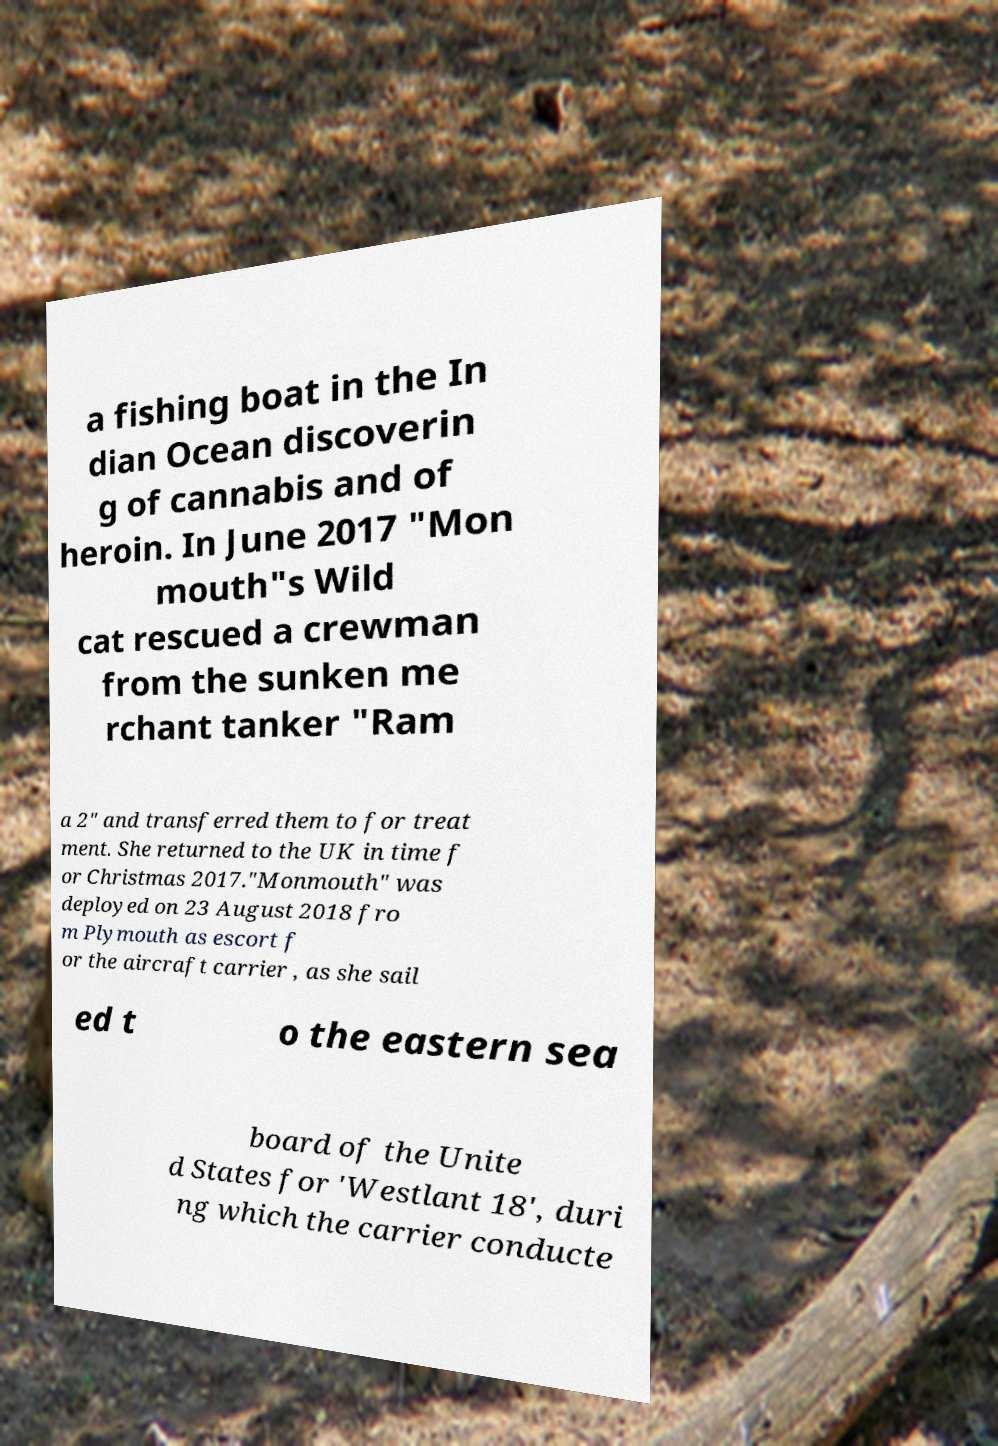For documentation purposes, I need the text within this image transcribed. Could you provide that? a fishing boat in the In dian Ocean discoverin g of cannabis and of heroin. In June 2017 "Mon mouth"s Wild cat rescued a crewman from the sunken me rchant tanker "Ram a 2" and transferred them to for treat ment. She returned to the UK in time f or Christmas 2017."Monmouth" was deployed on 23 August 2018 fro m Plymouth as escort f or the aircraft carrier , as she sail ed t o the eastern sea board of the Unite d States for 'Westlant 18', duri ng which the carrier conducte 